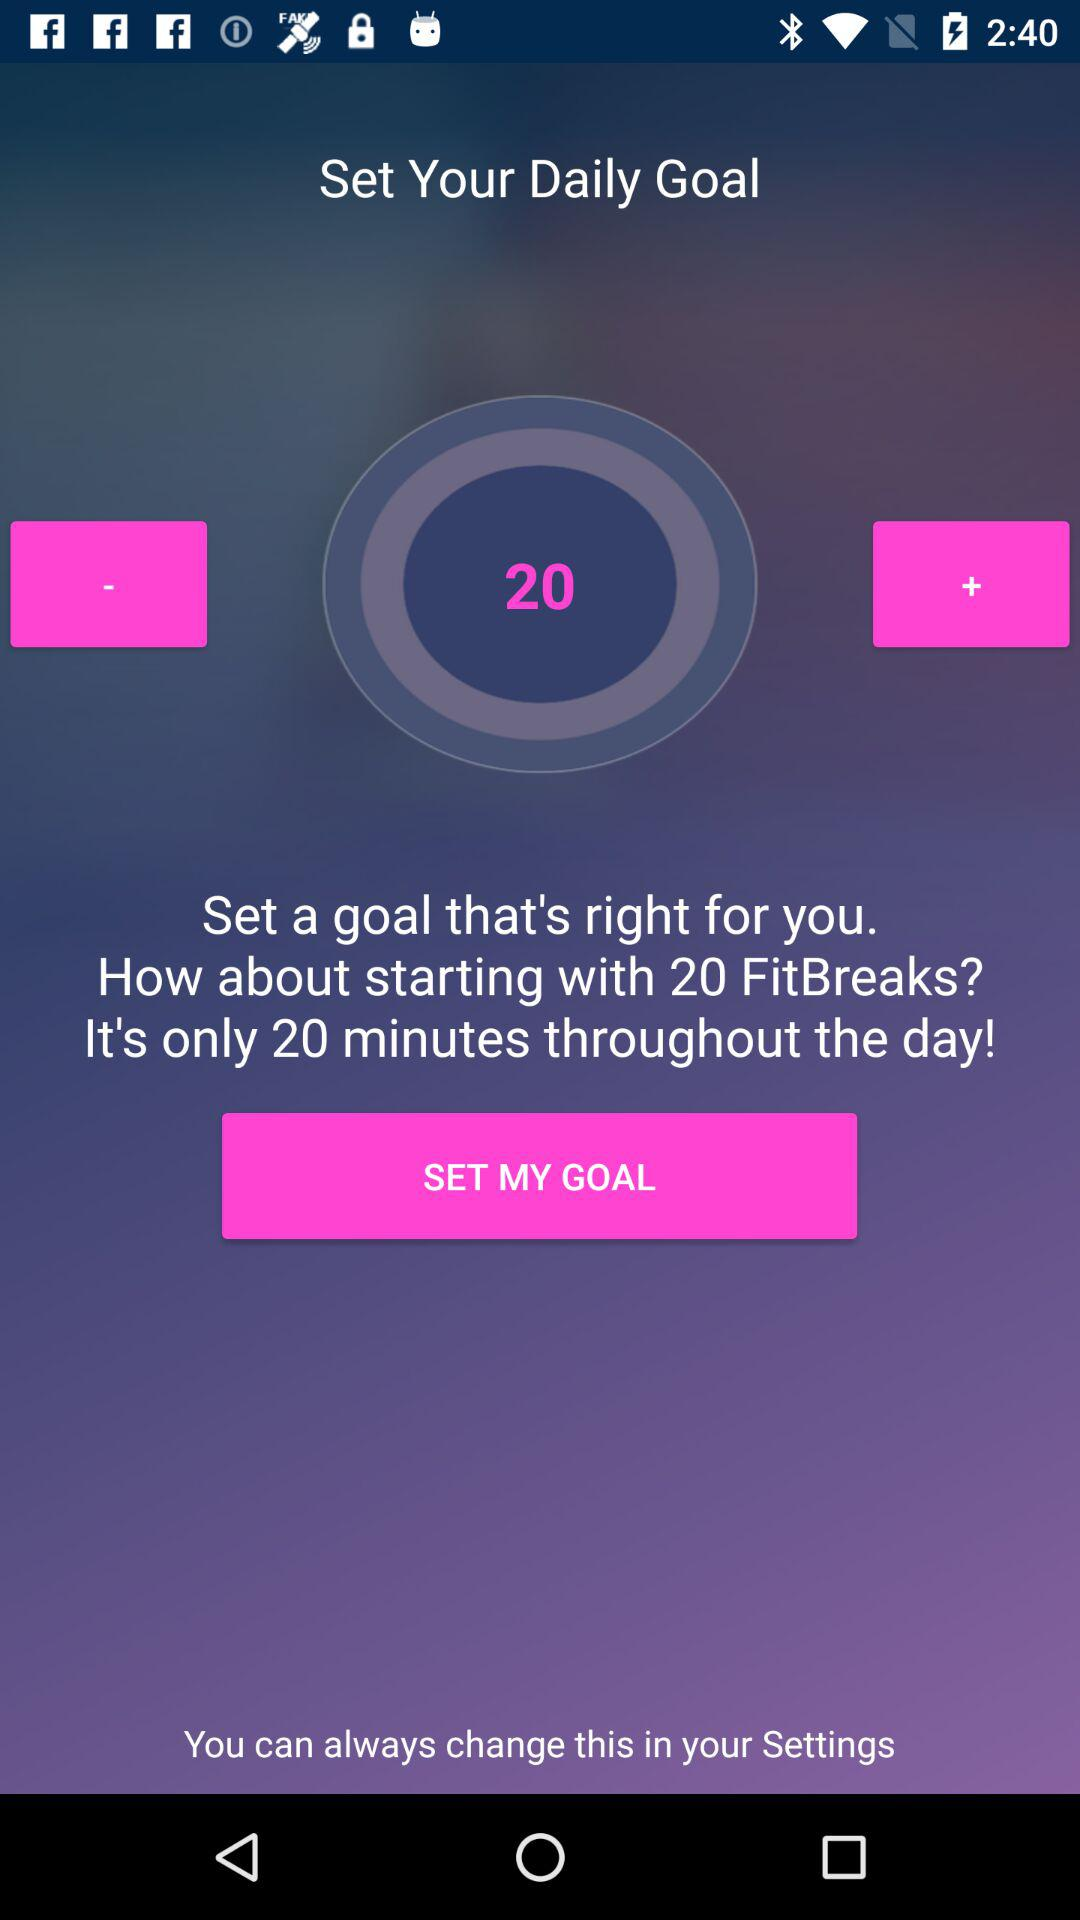How long is the daily goal target set for? The daily goal target is set for 20 minutes. 